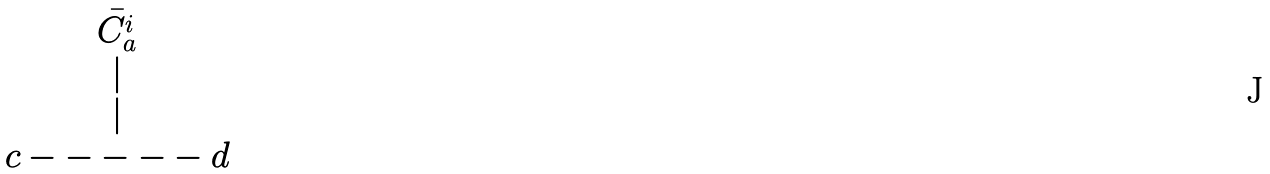<formula> <loc_0><loc_0><loc_500><loc_500>\begin{matrix} \bar { C _ { a } ^ { i } } \\ | \\ | \\ c - - - - - d \end{matrix}</formula> 